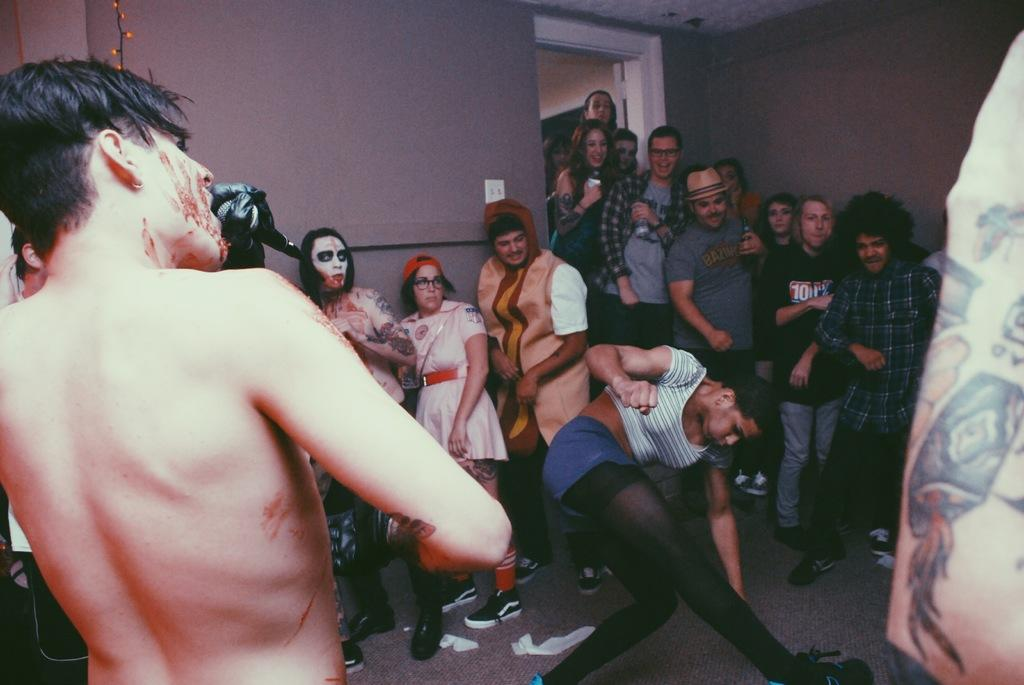What are the people in the image doing? The people in the image are standing. What specific action is being performed by one of the individuals? There is a woman dancing in the image. What can be seen in the background of the image? There is a wall and a door in the background of the image. Can you hear the horn of the car in the image? There is no car or horn present in the image. Where is the spot where the people are standing in the image? The provided facts do not specify the location of the spot where the people are standing. 